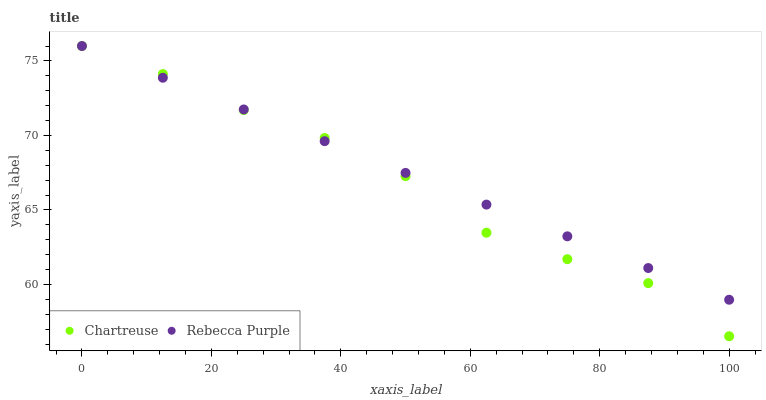Does Chartreuse have the minimum area under the curve?
Answer yes or no. Yes. Does Rebecca Purple have the maximum area under the curve?
Answer yes or no. Yes. Does Rebecca Purple have the minimum area under the curve?
Answer yes or no. No. Is Rebecca Purple the smoothest?
Answer yes or no. Yes. Is Chartreuse the roughest?
Answer yes or no. Yes. Is Rebecca Purple the roughest?
Answer yes or no. No. Does Chartreuse have the lowest value?
Answer yes or no. Yes. Does Rebecca Purple have the lowest value?
Answer yes or no. No. Does Rebecca Purple have the highest value?
Answer yes or no. Yes. Does Chartreuse intersect Rebecca Purple?
Answer yes or no. Yes. Is Chartreuse less than Rebecca Purple?
Answer yes or no. No. Is Chartreuse greater than Rebecca Purple?
Answer yes or no. No. 